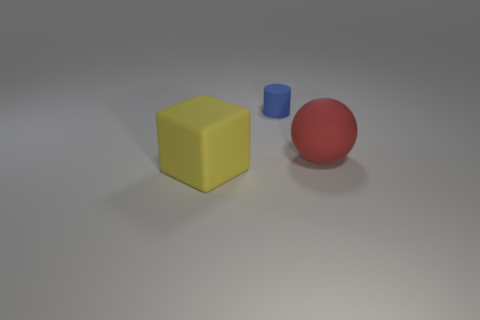What number of small things are made of the same material as the cylinder?
Your response must be concise. 0. What size is the object in front of the red ball in front of the blue thing?
Give a very brief answer. Large. There is a object left of the blue cylinder; does it have the same shape as the object behind the large matte ball?
Offer a terse response. No. Are there an equal number of large red things on the left side of the small matte object and small green objects?
Make the answer very short. Yes. What number of small objects are red objects or yellow things?
Offer a terse response. 0. The rubber ball is what size?
Keep it short and to the point. Large. Do the cylinder and the rubber thing in front of the matte ball have the same size?
Your response must be concise. No. How many purple things are either large rubber objects or balls?
Offer a very short reply. 0. What number of gray objects are there?
Offer a very short reply. 0. What is the size of the thing on the left side of the blue rubber object?
Your answer should be compact. Large. 